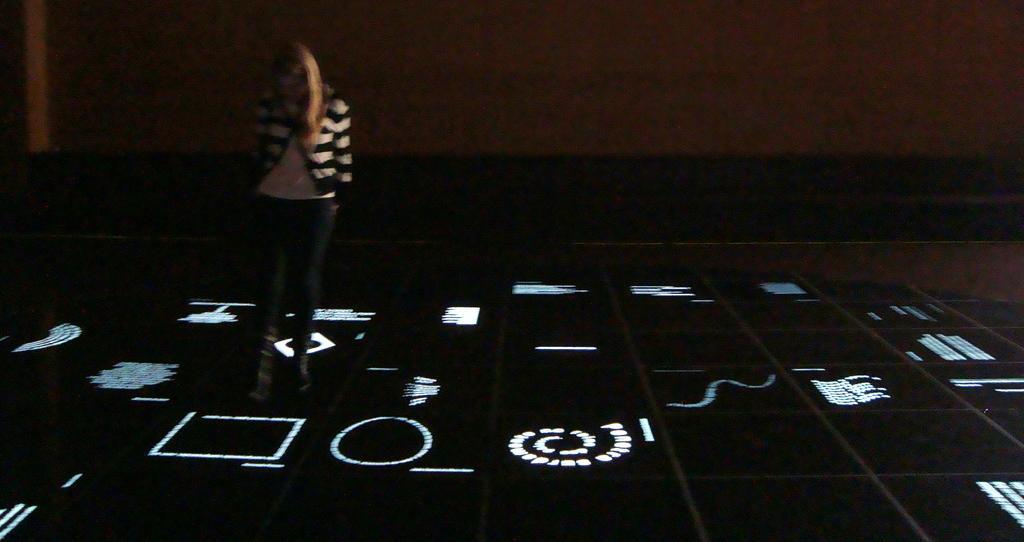Describe this image in one or two sentences. On the left side of the image a lady is standing. In the background of the image wall is there. At the bottom of the image floor is there. 